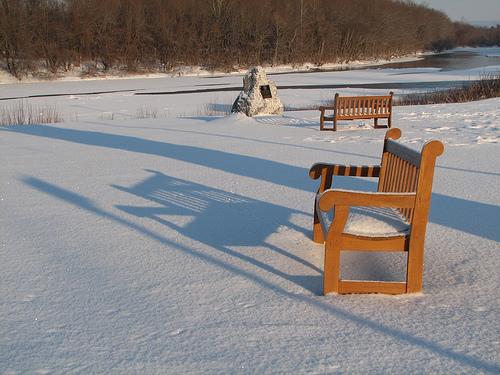Are the benches empty?
Short answer required. Yes. Can you see water?
Short answer required. Yes. What kind of area is this?
Give a very brief answer. Park. 